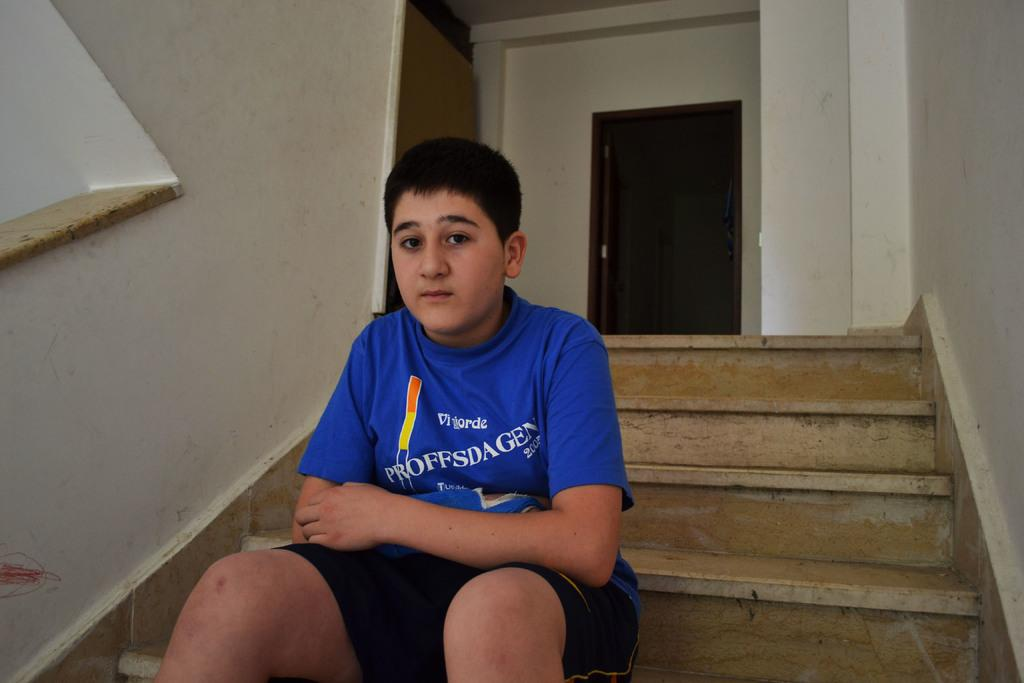<image>
Summarize the visual content of the image. A boy wears a blue shirt that says Proffsdagen on it. 